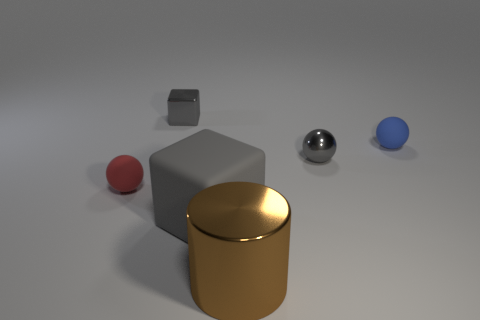The shiny object that is the same size as the matte block is what color?
Ensure brevity in your answer.  Brown. The block that is made of the same material as the blue thing is what color?
Your response must be concise. Gray. What number of objects are either rubber spheres left of the large matte cube or tiny spheres that are behind the red sphere?
Your answer should be very brief. 3. What size is the gray thing that is in front of the small ball on the left side of the metal object that is in front of the red rubber sphere?
Give a very brief answer. Large. Are there the same number of big brown cylinders that are left of the big gray object and small gray metallic things?
Your response must be concise. No. Is there anything else that is the same shape as the blue object?
Give a very brief answer. Yes. There is a large matte object; is it the same shape as the tiny metal object that is right of the metallic cylinder?
Make the answer very short. No. What size is the metal thing that is the same shape as the blue matte thing?
Keep it short and to the point. Small. What number of other things are there of the same material as the large brown thing
Provide a short and direct response. 2. What material is the big block?
Your response must be concise. Rubber. 